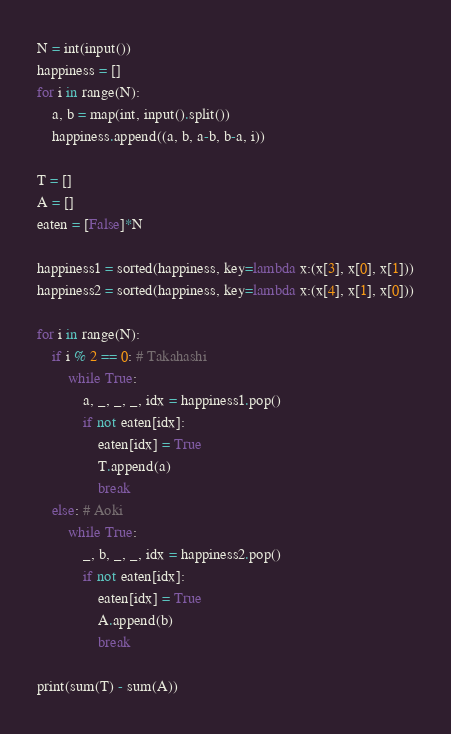Convert code to text. <code><loc_0><loc_0><loc_500><loc_500><_Python_>N = int(input())
happiness = []
for i in range(N):
    a, b = map(int, input().split())
    happiness.append((a, b, a-b, b-a, i))

T = []
A = []
eaten = [False]*N

happiness1 = sorted(happiness, key=lambda x:(x[3], x[0], x[1]))
happiness2 = sorted(happiness, key=lambda x:(x[4], x[1], x[0]))

for i in range(N):
    if i % 2 == 0: # Takahashi
        while True:
            a, _, _, _, idx = happiness1.pop()
            if not eaten[idx]:
                eaten[idx] = True
                T.append(a)
                break
    else: # Aoki
        while True:
            _, b, _, _, idx = happiness2.pop()
            if not eaten[idx]:
                eaten[idx] = True
                A.append(b)
                break

print(sum(T) - sum(A))</code> 